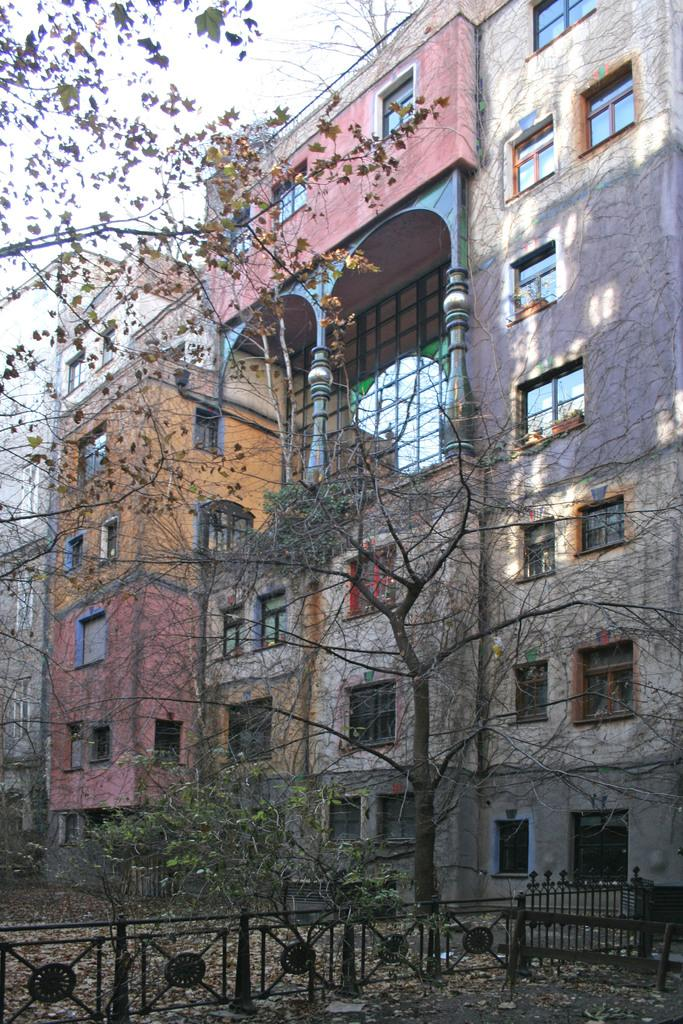What type of structure can be seen in the image? There is a fence in the image. What other objects or features can be seen in the image? There are trees and buildings in the image. What can be seen in the background of the image? The sky is visible in the background of the image. What type of soup is being served in the image? There is no soup present in the image. Is there a sweater visible on anyone in the image? There is no sweater visible in the image. 